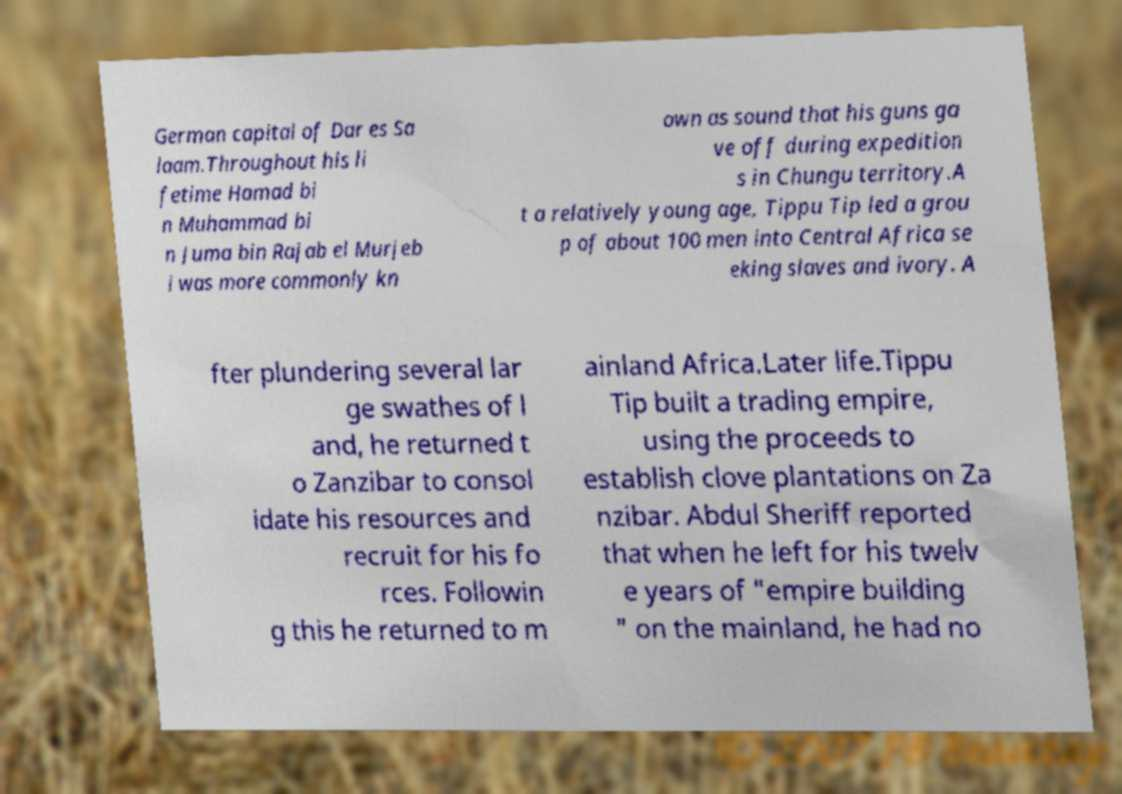Please read and relay the text visible in this image. What does it say? German capital of Dar es Sa laam.Throughout his li fetime Hamad bi n Muhammad bi n Juma bin Rajab el Murjeb i was more commonly kn own as sound that his guns ga ve off during expedition s in Chungu territory.A t a relatively young age, Tippu Tip led a grou p of about 100 men into Central Africa se eking slaves and ivory. A fter plundering several lar ge swathes of l and, he returned t o Zanzibar to consol idate his resources and recruit for his fo rces. Followin g this he returned to m ainland Africa.Later life.Tippu Tip built a trading empire, using the proceeds to establish clove plantations on Za nzibar. Abdul Sheriff reported that when he left for his twelv e years of "empire building " on the mainland, he had no 